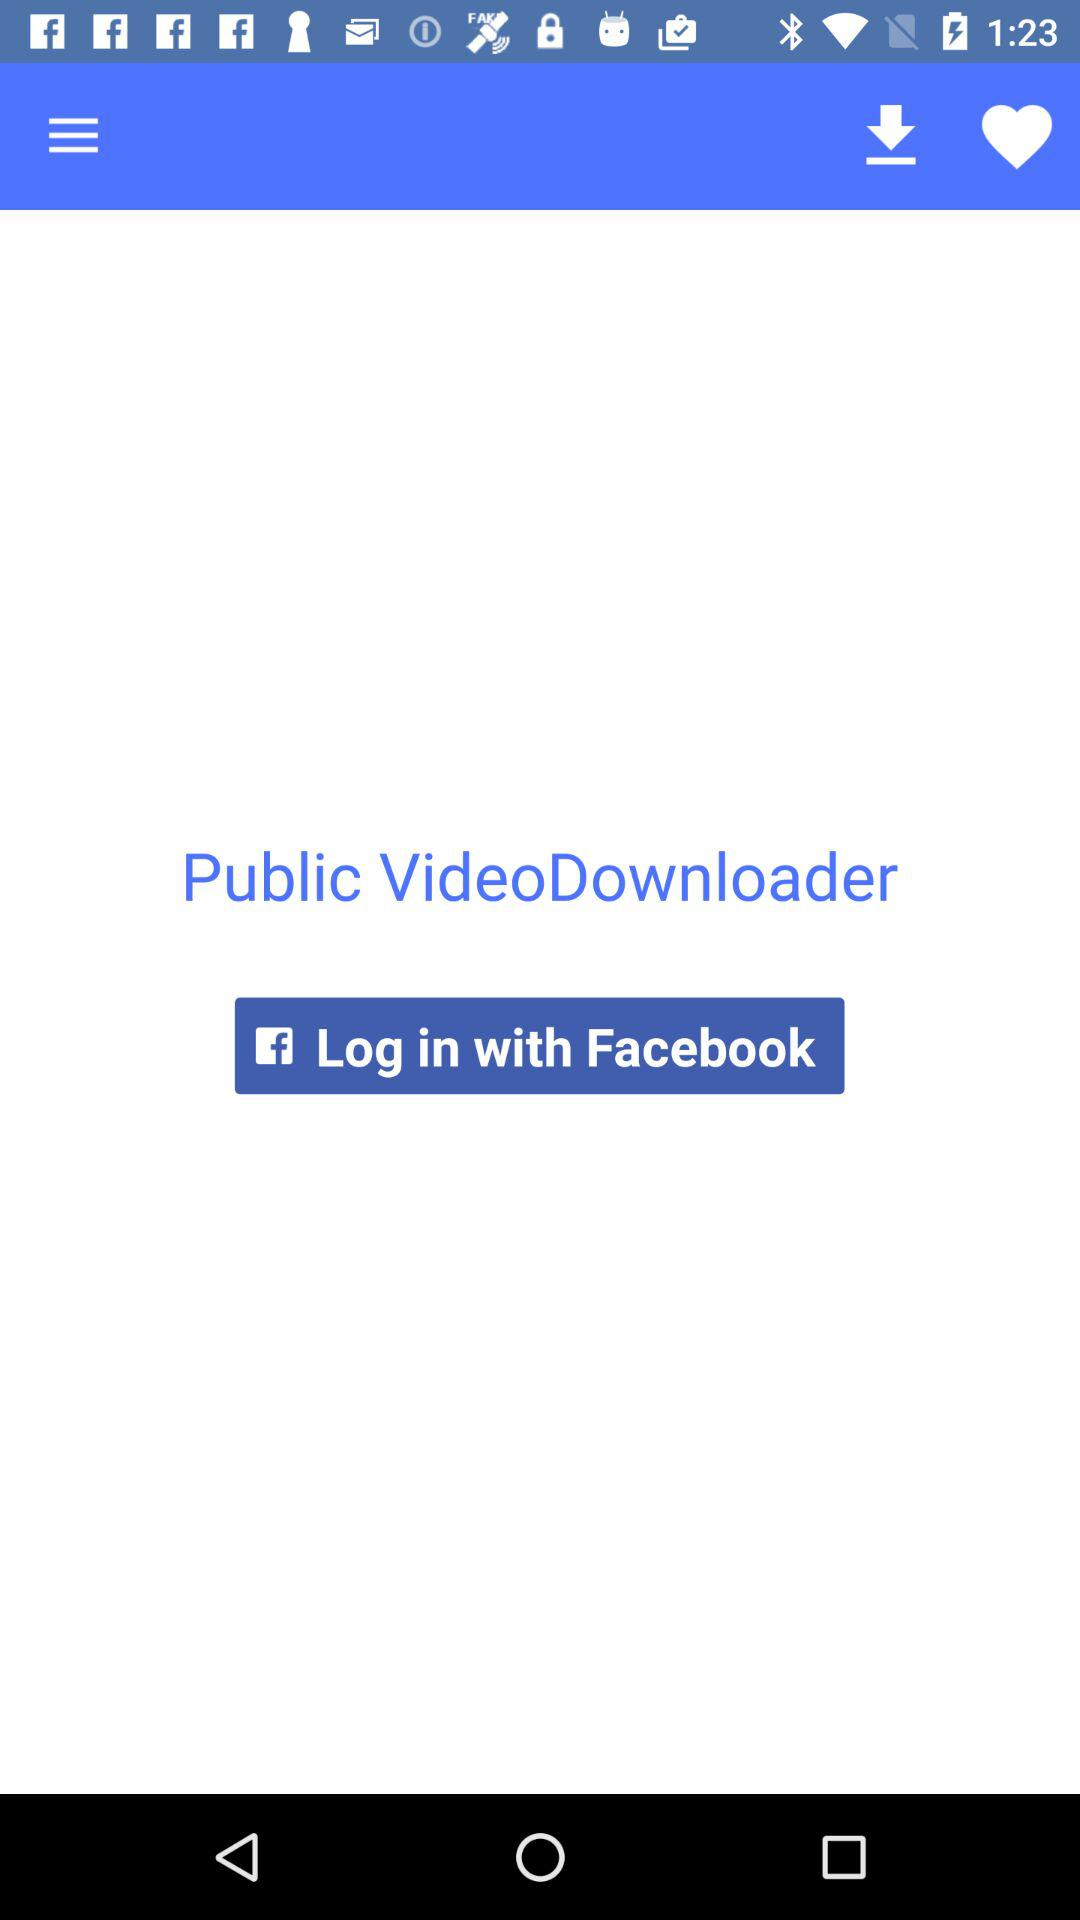What is the app title? The app title is "Public VideoDownloader". 